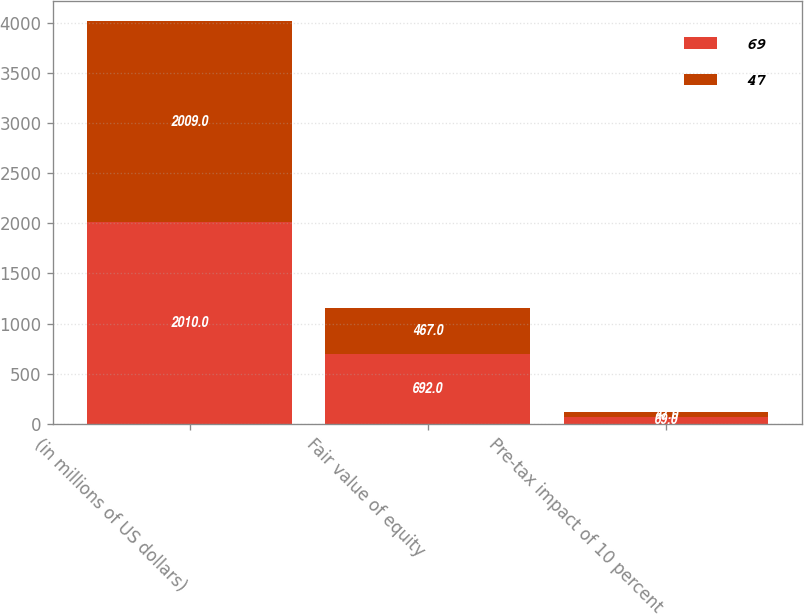<chart> <loc_0><loc_0><loc_500><loc_500><stacked_bar_chart><ecel><fcel>(in millions of US dollars)<fcel>Fair value of equity<fcel>Pre-tax impact of 10 percent<nl><fcel>69<fcel>2010<fcel>692<fcel>69<nl><fcel>47<fcel>2009<fcel>467<fcel>47<nl></chart> 